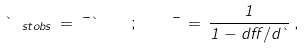<formula> <loc_0><loc_0><loc_500><loc_500>\theta _ { \ s t { o b s } } \, = \, \mu \theta \, \quad ; \quad \mu \, = \, \frac { 1 } { 1 - d \alpha / d \theta } \, ,</formula> 